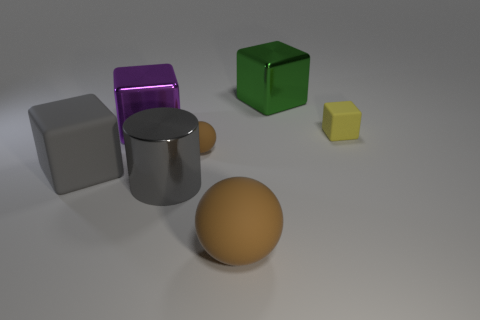There is a purple thing that is the same shape as the yellow rubber thing; what material is it?
Your answer should be very brief. Metal. How many shiny cubes are in front of the big brown object in front of the green object?
Your answer should be compact. 0. How big is the matte sphere behind the sphere in front of the brown rubber object that is behind the big gray cylinder?
Your response must be concise. Small. What is the color of the matte object on the left side of the large shiny thing in front of the yellow block?
Keep it short and to the point. Gray. What number of other objects are there of the same material as the gray cylinder?
Offer a terse response. 2. How many other things are the same color as the big cylinder?
Keep it short and to the point. 1. What material is the small block that is behind the brown matte thing behind the gray block?
Your answer should be very brief. Rubber. Are there any small red cubes?
Make the answer very short. No. What is the size of the matte block that is on the right side of the cube that is in front of the yellow block?
Give a very brief answer. Small. Are there more big metal cubes to the right of the big purple cube than purple objects on the right side of the large green shiny thing?
Offer a very short reply. Yes. 